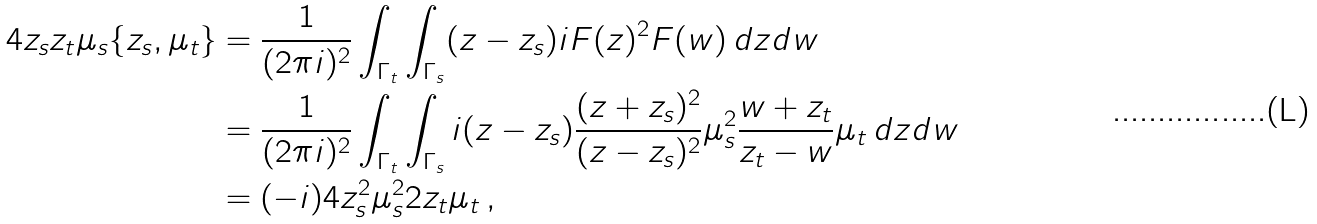Convert formula to latex. <formula><loc_0><loc_0><loc_500><loc_500>4 z _ { s } z _ { t } \mu _ { s } \{ z _ { s } , \mu _ { t } \} & = \frac { 1 } { ( 2 \pi i ) ^ { 2 } } \int _ { \Gamma _ { t } } \int _ { \Gamma _ { s } } ( z - z _ { s } ) i F ( z ) ^ { 2 } F ( w ) \, d z d w \\ & = \frac { 1 } { ( 2 \pi i ) ^ { 2 } } \int _ { \Gamma _ { t } } \int _ { \Gamma _ { s } } i ( z - z _ { s } ) \frac { ( z + z _ { s } ) ^ { 2 } } { ( z - z _ { s } ) ^ { 2 } } \mu _ { s } ^ { 2 } \frac { w + z _ { t } } { z _ { t } - w } \mu _ { t } \, d z d w \\ & = ( - i ) 4 z _ { s } ^ { 2 } \mu _ { s } ^ { 2 } 2 z _ { t } \mu _ { t } \, ,</formula> 